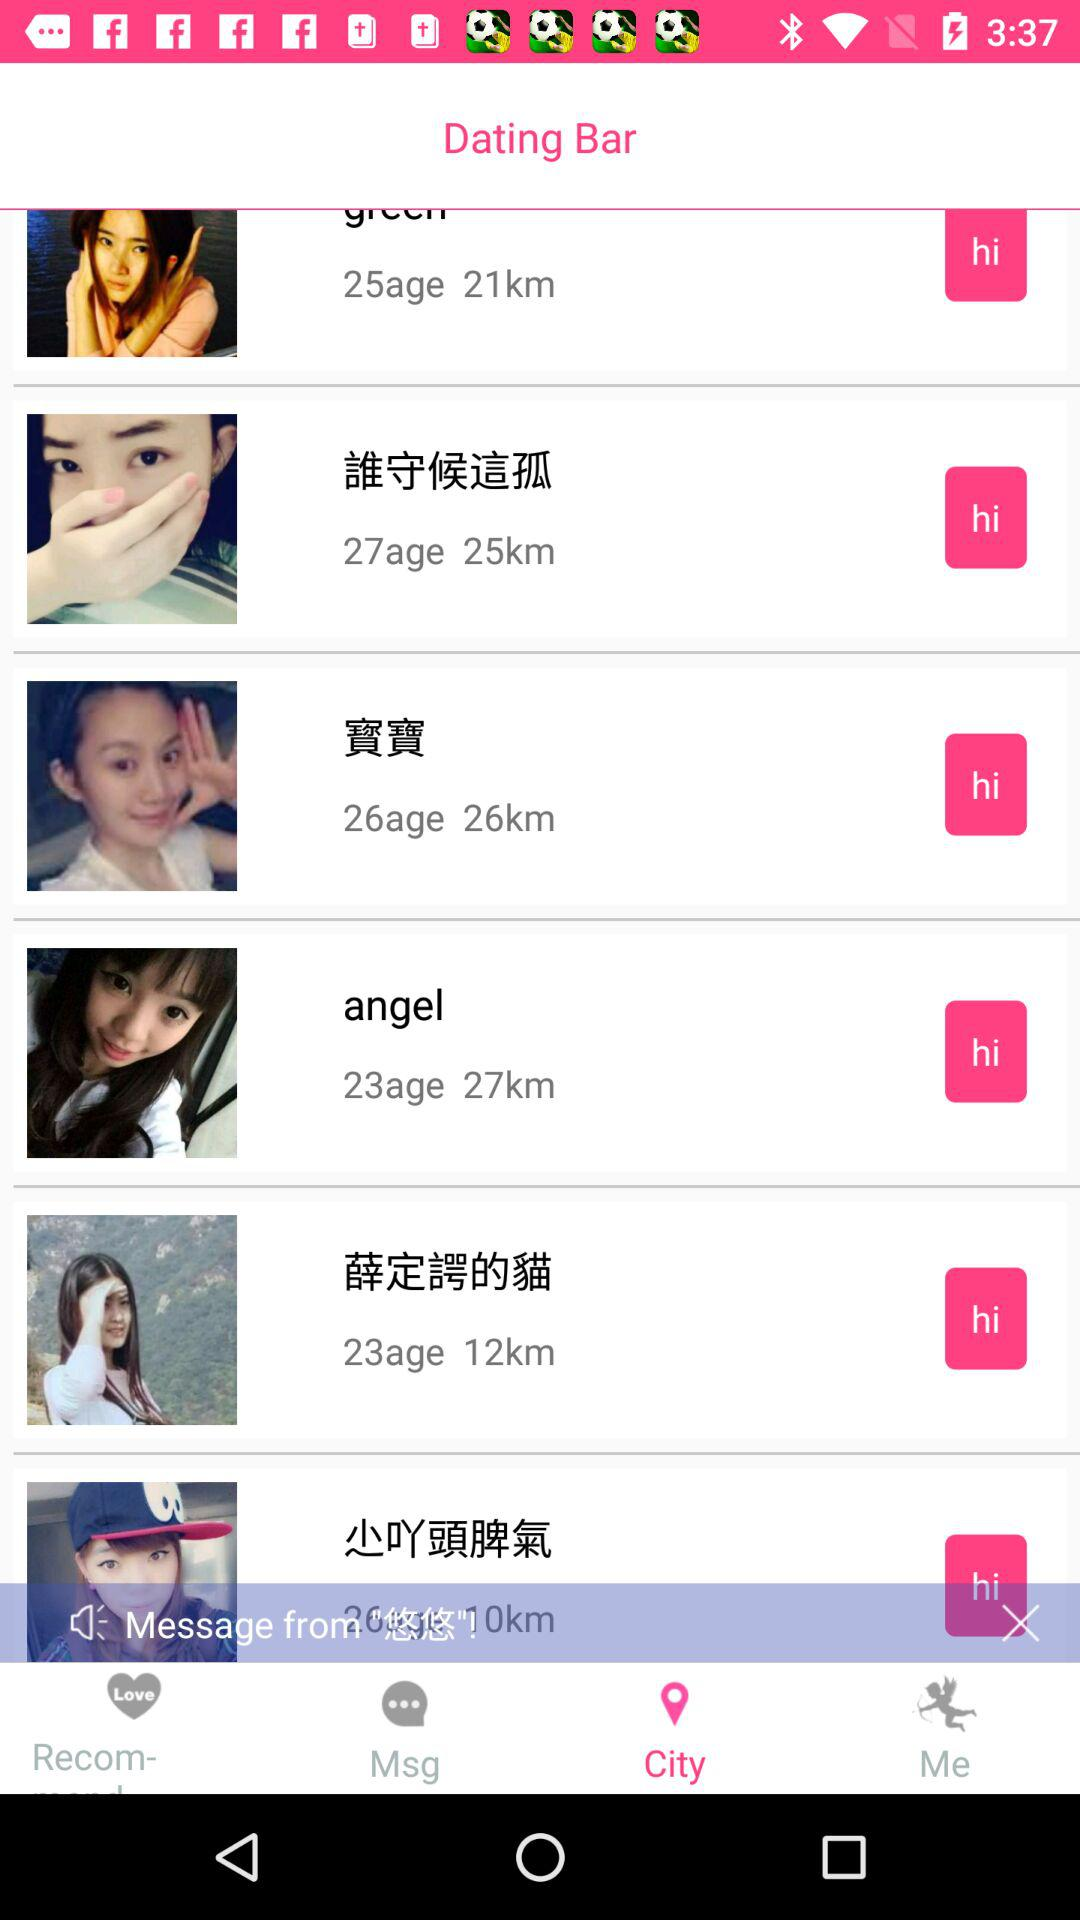What is Angel's age? Angel's age is 23 years. 